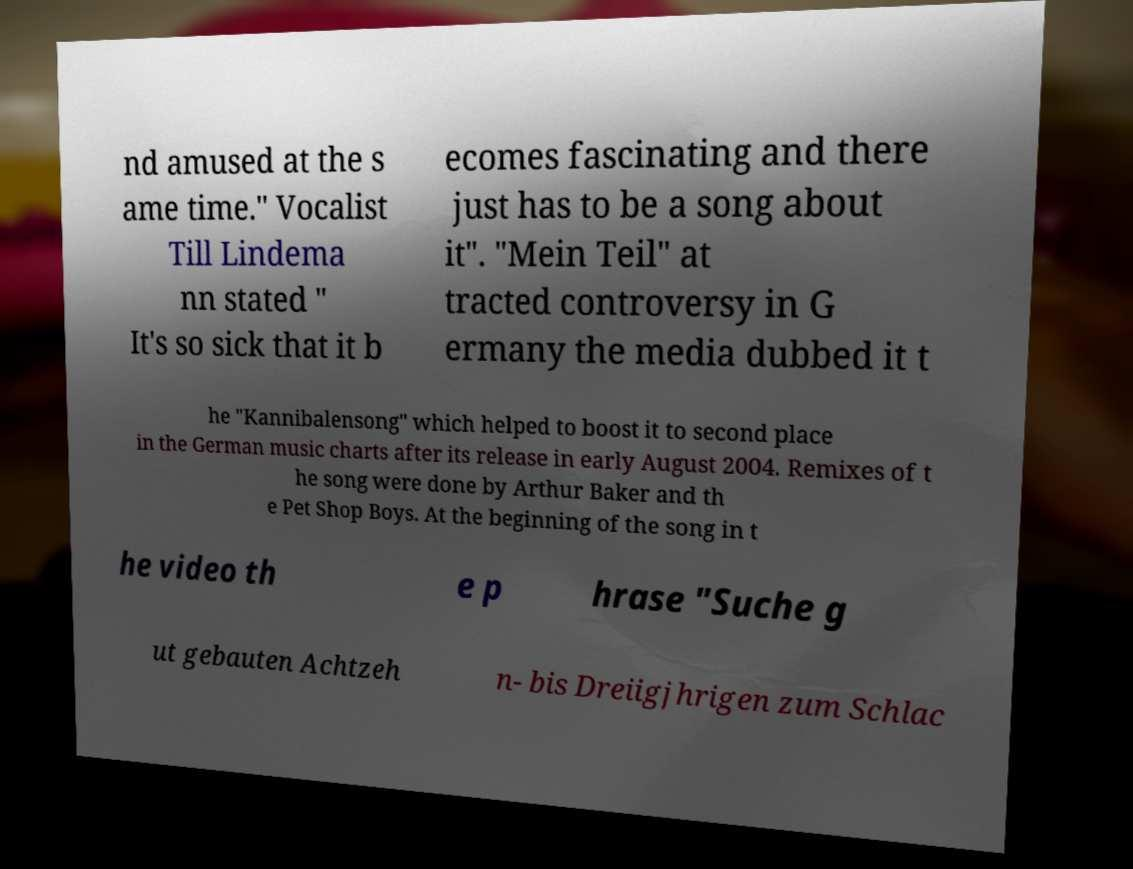Please identify and transcribe the text found in this image. nd amused at the s ame time." Vocalist Till Lindema nn stated " It's so sick that it b ecomes fascinating and there just has to be a song about it". "Mein Teil" at tracted controversy in G ermany the media dubbed it t he "Kannibalensong" which helped to boost it to second place in the German music charts after its release in early August 2004. Remixes of t he song were done by Arthur Baker and th e Pet Shop Boys. At the beginning of the song in t he video th e p hrase "Suche g ut gebauten Achtzeh n- bis Dreiigjhrigen zum Schlac 